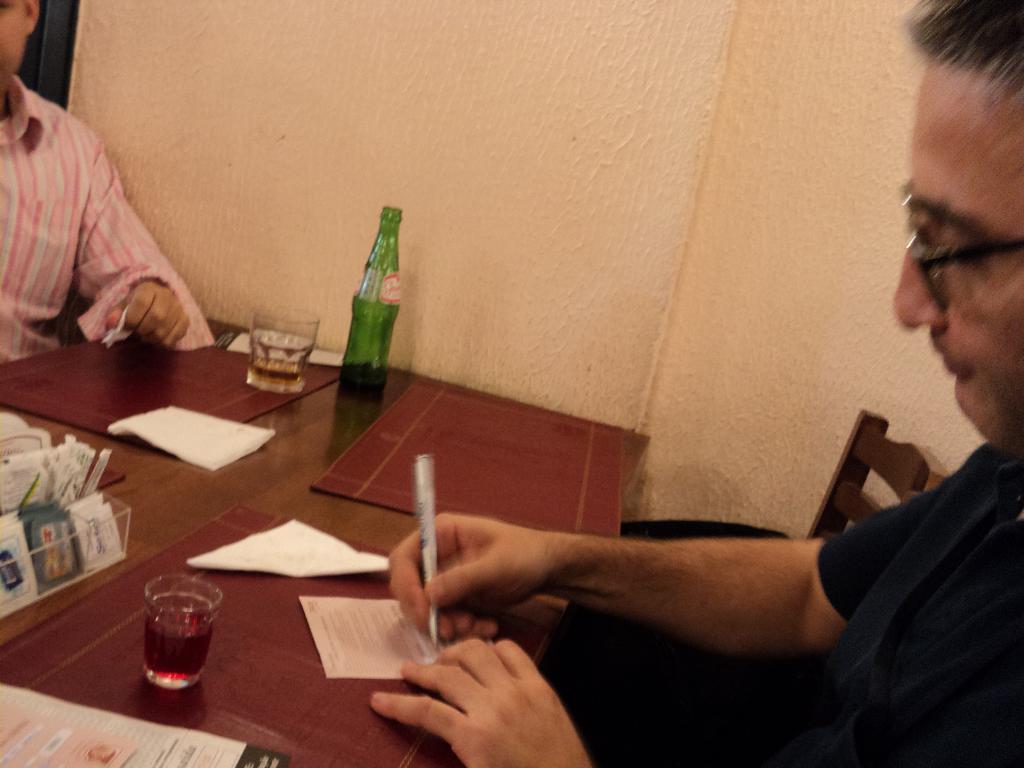Can you describe this image briefly? Here we can see two men sitting on a chair in front of a table and on the table we can see table mats, glasses and drink init, bottle, papers. This man is writing something on a paper by holding a pen in his hand. This is a wall in cream colour. 